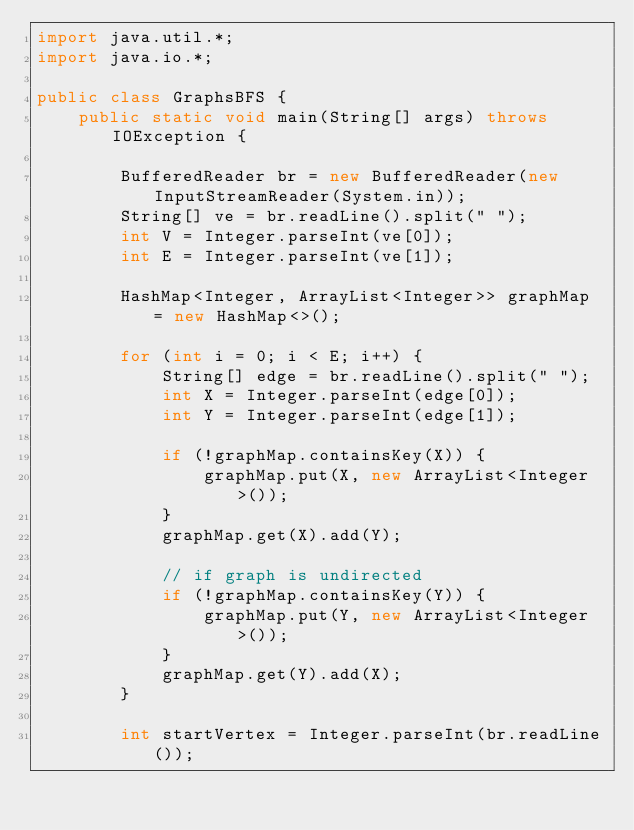Convert code to text. <code><loc_0><loc_0><loc_500><loc_500><_Java_>import java.util.*;
import java.io.*;

public class GraphsBFS {
    public static void main(String[] args) throws IOException {

        BufferedReader br = new BufferedReader(new InputStreamReader(System.in));
        String[] ve = br.readLine().split(" ");
        int V = Integer.parseInt(ve[0]);
        int E = Integer.parseInt(ve[1]);

        HashMap<Integer, ArrayList<Integer>> graphMap = new HashMap<>();

        for (int i = 0; i < E; i++) {
            String[] edge = br.readLine().split(" ");
            int X = Integer.parseInt(edge[0]);
            int Y = Integer.parseInt(edge[1]);

            if (!graphMap.containsKey(X)) {
                graphMap.put(X, new ArrayList<Integer>());
            }
            graphMap.get(X).add(Y);

            // if graph is undirected
            if (!graphMap.containsKey(Y)) {
                graphMap.put(Y, new ArrayList<Integer>());
            }
            graphMap.get(Y).add(X);
        }

        int startVertex = Integer.parseInt(br.readLine());
</code> 